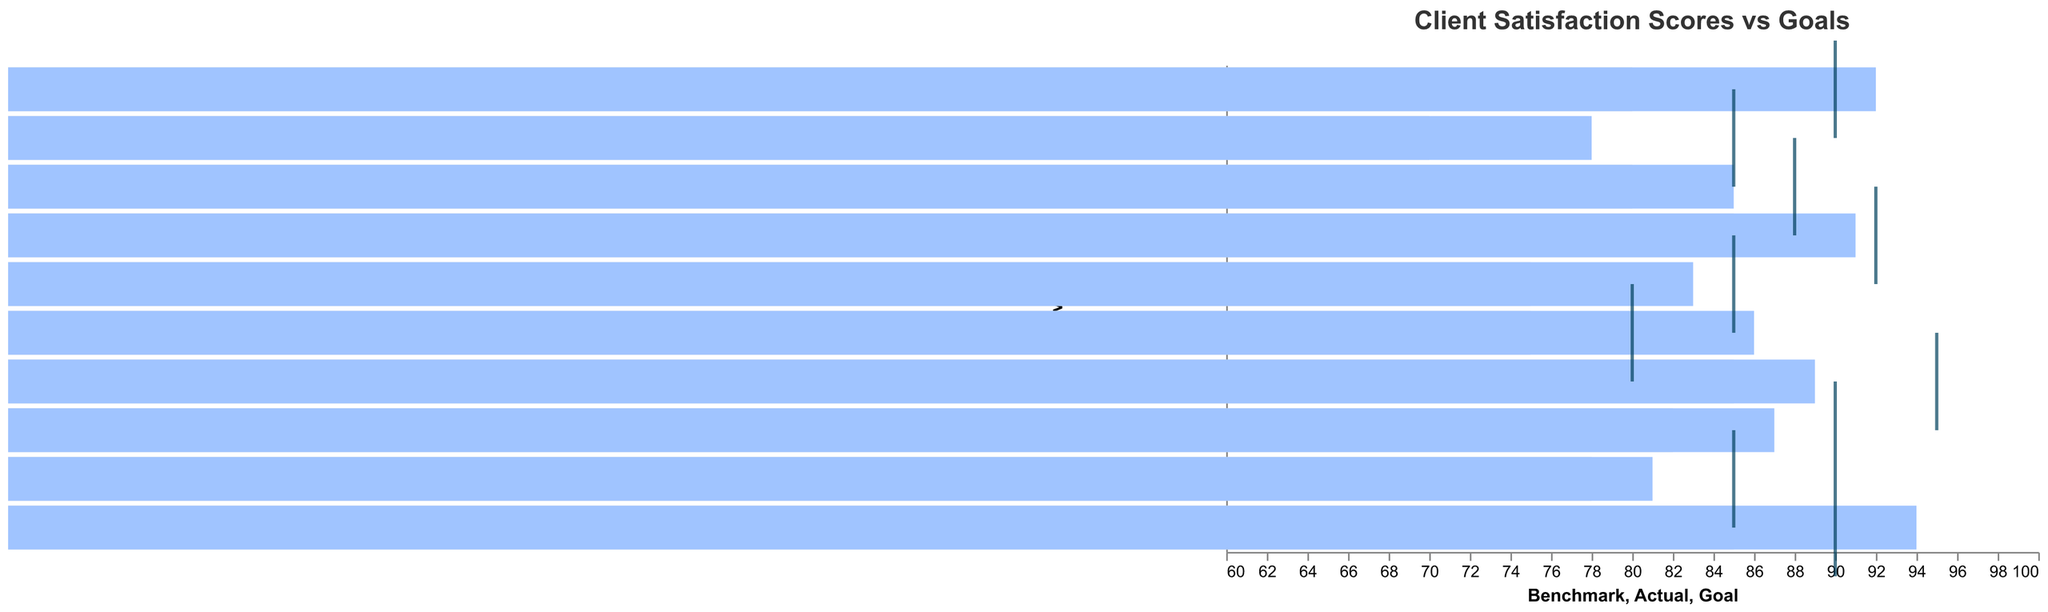How many legal services have an actual satisfaction score higher than the goal? Look at each service's actual score and compare it to the goal score. Count how many actual scores are higher than their corresponding goals.
Answer: 4 Which legal service has the highest actual satisfaction score? Identify the highest value in the 'Actual' column from the data and then find the corresponding legal service.
Answer: Tax Law How does Corporate Law's actual satisfaction score compare to its goal? Compare the 'Actual' score of 92 for Corporate Law to its 'Goal' score of 90. Since 92 is greater than 90, it exceeds the goal.
Answer: Exceeds goal Which services did not meet their goal satisfaction scores? Compare each service's 'Actual' score with its 'Goal' score and list those where the 'Actual' score is less than the 'Goal' score.
Answer: Criminal Defense, Family Law, Real Estate Law, Employment Law, Estate Planning For which service is the difference between the actual score and the goal score the largest, and what is the difference? Calculate the difference between the 'Actual' and 'Goal' scores for each service. The largest difference is determined by finding the maximum value. 'Intellectual Property' has the largest difference with a value of -6.
Answer: Intellectual Property, 6 What is the average benchmark score across all services? Sum all the benchmark scores and divide by the number of services to get the average. (70+80+75+85+75+78+82+85+80+85)/10 = 79.5
Answer: 79.5 How many services have an actual score that is below the benchmark score? Compare each service's 'Actual' score to its 'Benchmark' score and count the number of services where the 'Actual' score is less than the 'Benchmark' score.
Answer: 0 Which services have exceeded both the goal and benchmark scores? Identify which services have actual scores higher than both their goal and benchmark scores by comparing the 'Actual' score to both the 'Goal' and 'Benchmark' scores for each service.
Answer: Corporate Law, Immigration Law, Tax Law How much higher is the actual score of Tax Law compared to its benchmark? Calculate the difference between the 'Actual' score (94) and the 'Benchmark' score (85) for Tax Law.
Answer: 9 Which service has the smallest difference between its actual satisfaction score and its goal? Calculate the absolute difference between the 'Actual' and 'Goal' scores for each service. The smallest difference is found for Corporate Law, which has a difference of 2.
Answer: Corporate Law 